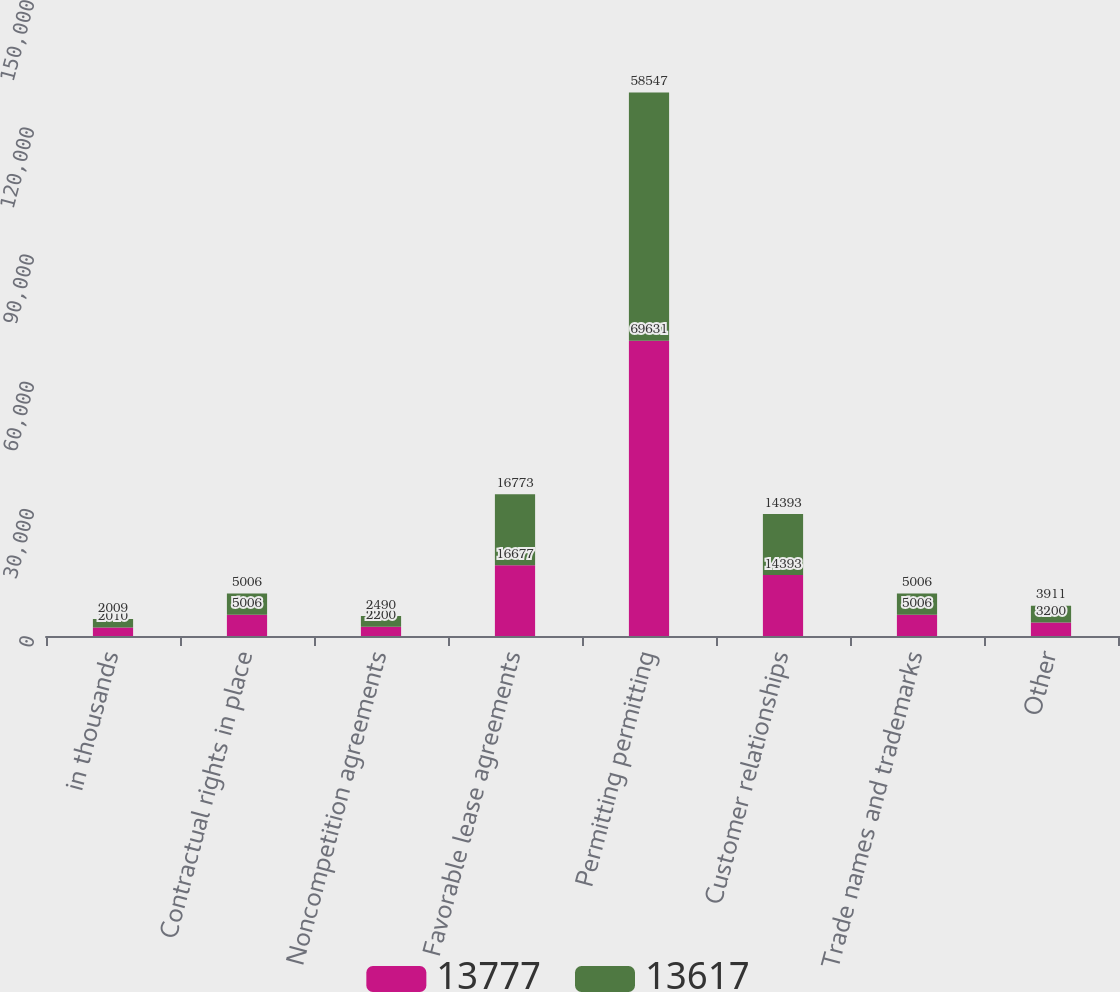Convert chart. <chart><loc_0><loc_0><loc_500><loc_500><stacked_bar_chart><ecel><fcel>in thousands<fcel>Contractual rights in place<fcel>Noncompetition agreements<fcel>Favorable lease agreements<fcel>Permitting permitting<fcel>Customer relationships<fcel>Trade names and trademarks<fcel>Other<nl><fcel>13777<fcel>2010<fcel>5006<fcel>2200<fcel>16677<fcel>69631<fcel>14393<fcel>5006<fcel>3200<nl><fcel>13617<fcel>2009<fcel>5006<fcel>2490<fcel>16773<fcel>58547<fcel>14393<fcel>5006<fcel>3911<nl></chart> 